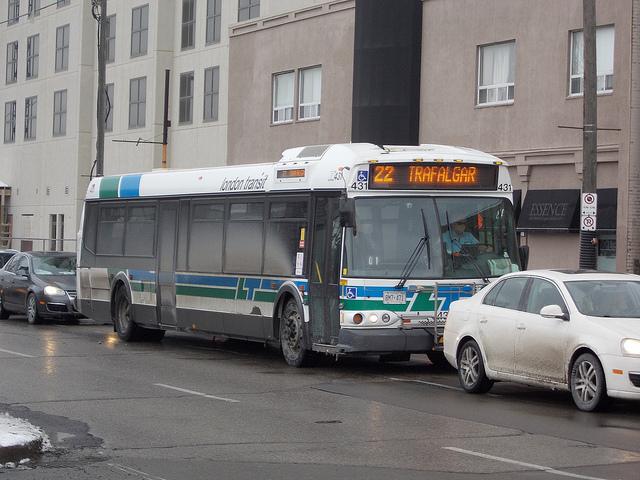Has it been raining?
Write a very short answer. Yes. What is in front of the bus?
Short answer required. Car. Is the bus going to Trafalgar?
Keep it brief. Yes. Is the building on the right round?
Keep it brief. No. What country is this?
Answer briefly. Usa. 